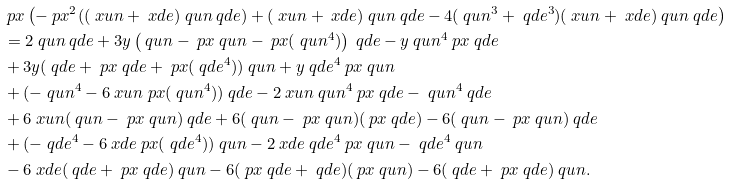Convert formula to latex. <formula><loc_0><loc_0><loc_500><loc_500>& \ p x \left ( - \ p x ^ { 2 } ( ( \ x u n + \ x d e ) \ q u n \ q d e ) + ( \ x u n + \ x d e ) \ q u n \ q d e - 4 ( \ q u n ^ { 3 } + \ q d e ^ { 3 } ) ( \ x u n + \ x d e ) \ q u n \ q d e \right ) \\ & = 2 \ q u n \ q d e + 3 y \left ( \ q u n - \ p x \ q u n - \ p x ( \ q u n ^ { 4 } ) \right ) \ q d e - y \ q u n ^ { 4 } \ p x \ q d e \\ & + 3 y ( \ q d e + \ p x \ q d e + \ p x ( \ q d e ^ { 4 } ) ) \ q u n + y \ q d e ^ { 4 } \ p x \ q u n \\ & + ( - \ q u n ^ { 4 } - 6 \ x u n \ p x ( \ q u n ^ { 4 } ) ) \ q d e - 2 \ x u n \ q u n ^ { 4 } \ p x \ q d e - \ q u n ^ { 4 } \ q d e \\ & + 6 \ x u n ( \ q u n - \ p x \ q u n ) \ q d e + 6 ( \ q u n - \ p x \ q u n ) ( \ p x \ q d e ) - 6 ( \ q u n - \ p x \ q u n ) \ q d e \\ & + ( - \ q d e ^ { 4 } - 6 \ x d e \ p x ( \ q d e ^ { 4 } ) ) \ q u n - 2 \ x d e \ q d e ^ { 4 } \ p x \ q u n - \ q d e ^ { 4 } \ q u n \\ & - 6 \ x d e ( \ q d e + \ p x \ q d e ) \ q u n - 6 ( \ p x \ q d e + \ q d e ) ( \ p x \ q u n ) - 6 ( \ q d e + \ p x \ q d e ) \ q u n .</formula> 